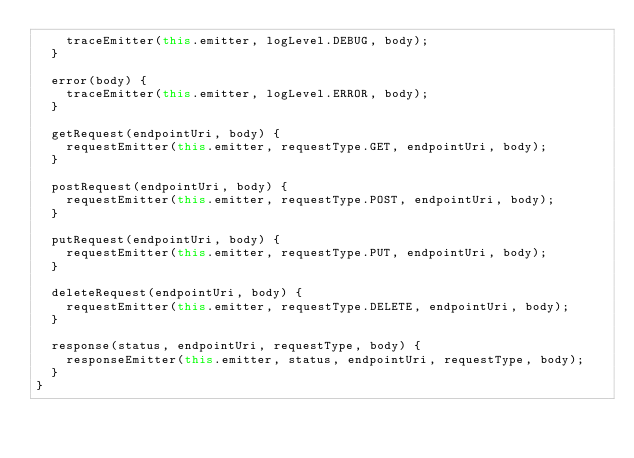Convert code to text. <code><loc_0><loc_0><loc_500><loc_500><_JavaScript_>		traceEmitter(this.emitter, logLevel.DEBUG, body);
	}

	error(body) {
		traceEmitter(this.emitter, logLevel.ERROR, body);
	}

	getRequest(endpointUri, body) {
		requestEmitter(this.emitter, requestType.GET, endpointUri, body);
	}

	postRequest(endpointUri, body) {
		requestEmitter(this.emitter, requestType.POST, endpointUri, body);
	}

	putRequest(endpointUri, body) {
		requestEmitter(this.emitter, requestType.PUT, endpointUri, body);
	}

	deleteRequest(endpointUri, body) {
		requestEmitter(this.emitter, requestType.DELETE, endpointUri, body);
	}

	response(status, endpointUri, requestType, body) {
		responseEmitter(this.emitter, status, endpointUri, requestType, body);
	}
}</code> 